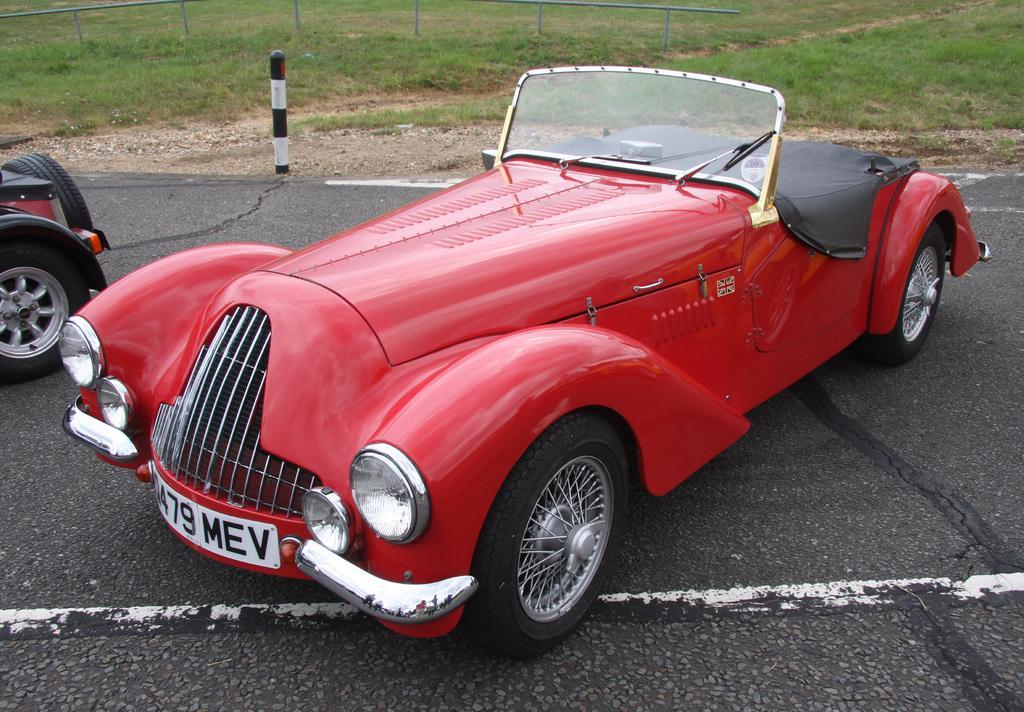How would you summarize this image in a sentence or two? In the picture I can see vehicles on the road among them the vehicle on the right side is red in color. In the background I can see poles, the grass and some other objects. 